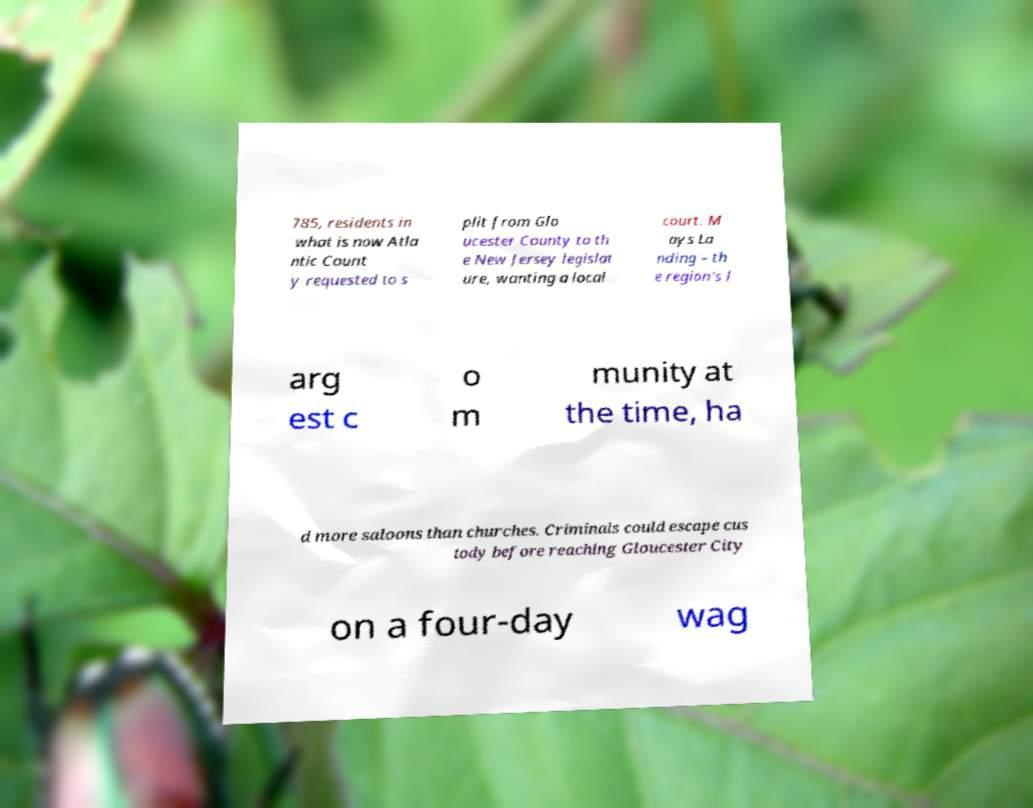What messages or text are displayed in this image? I need them in a readable, typed format. 785, residents in what is now Atla ntic Count y requested to s plit from Glo ucester County to th e New Jersey legislat ure, wanting a local court. M ays La nding – th e region's l arg est c o m munity at the time, ha d more saloons than churches. Criminals could escape cus tody before reaching Gloucester City on a four-day wag 